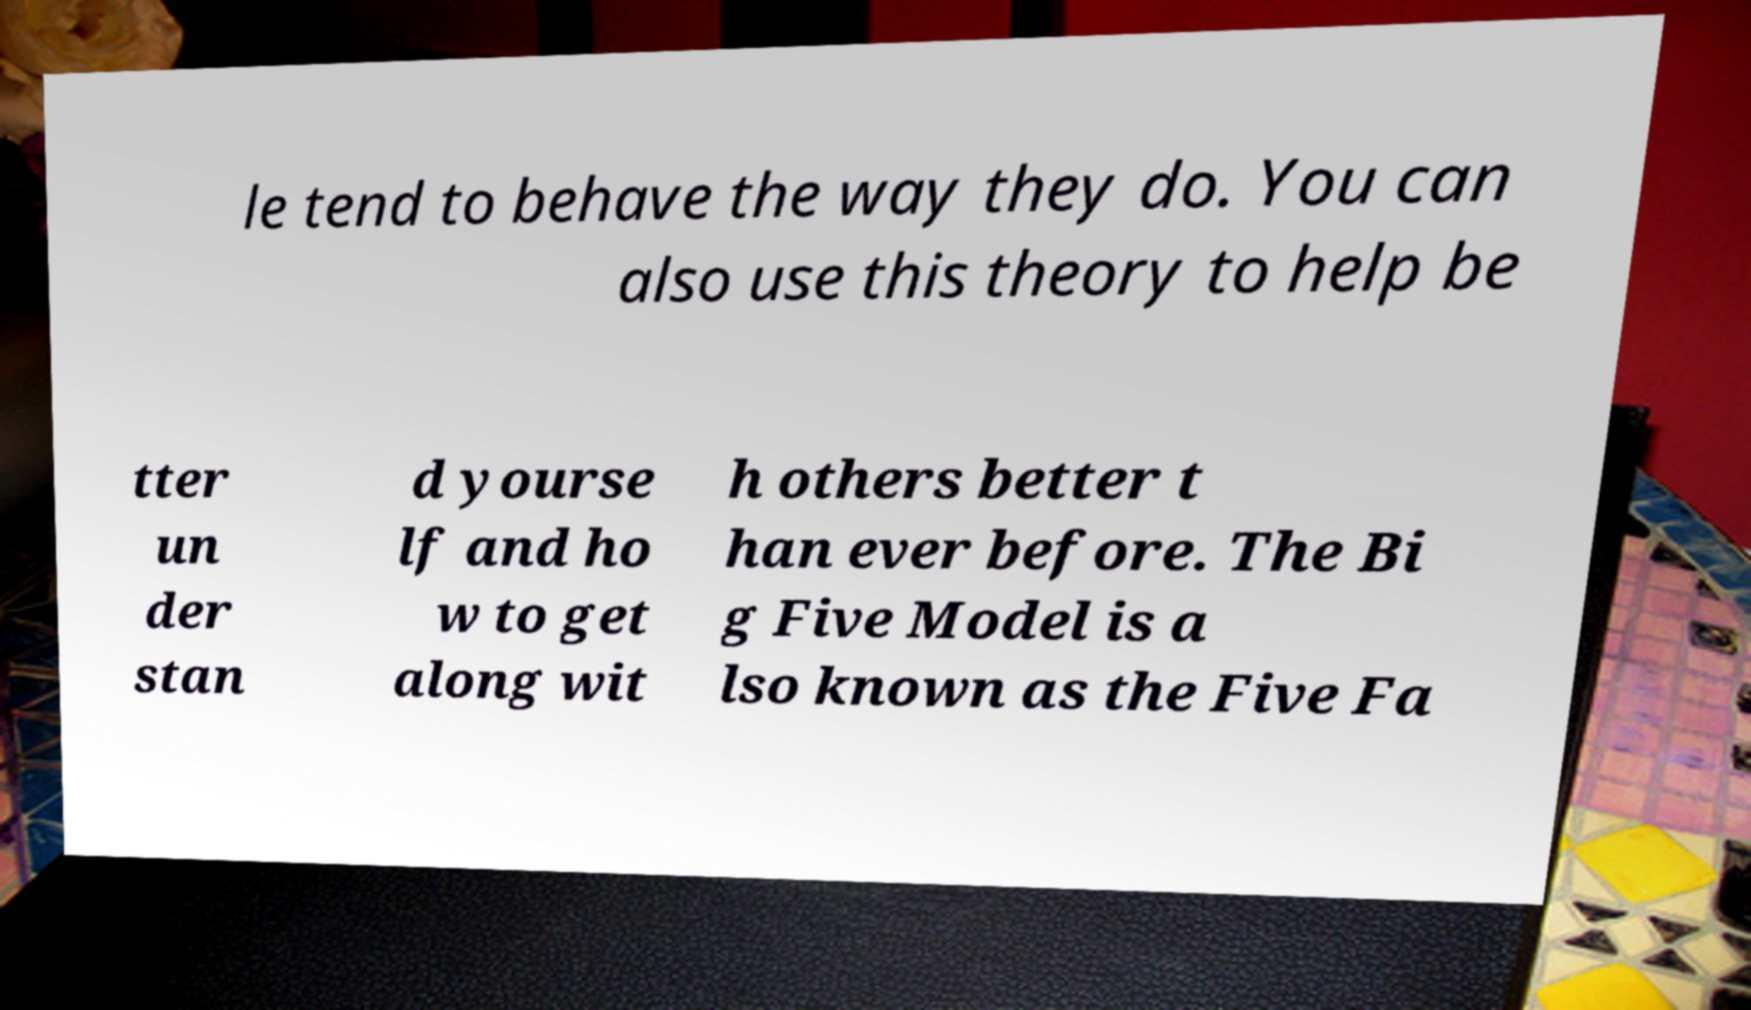There's text embedded in this image that I need extracted. Can you transcribe it verbatim? le tend to behave the way they do. You can also use this theory to help be tter un der stan d yourse lf and ho w to get along wit h others better t han ever before. The Bi g Five Model is a lso known as the Five Fa 